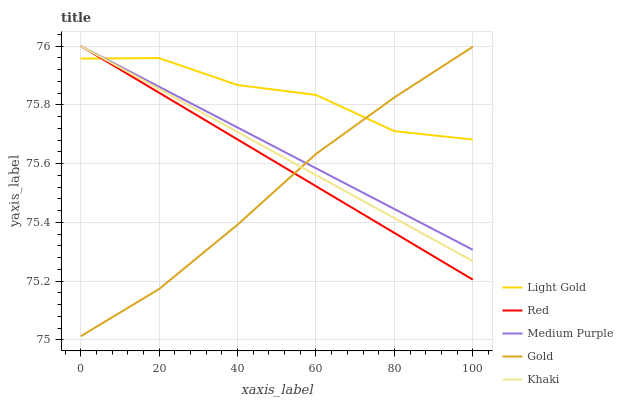Does Khaki have the minimum area under the curve?
Answer yes or no. No. Does Khaki have the maximum area under the curve?
Answer yes or no. No. Is Khaki the smoothest?
Answer yes or no. No. Is Khaki the roughest?
Answer yes or no. No. Does Khaki have the lowest value?
Answer yes or no. No. Does Light Gold have the highest value?
Answer yes or no. No. 